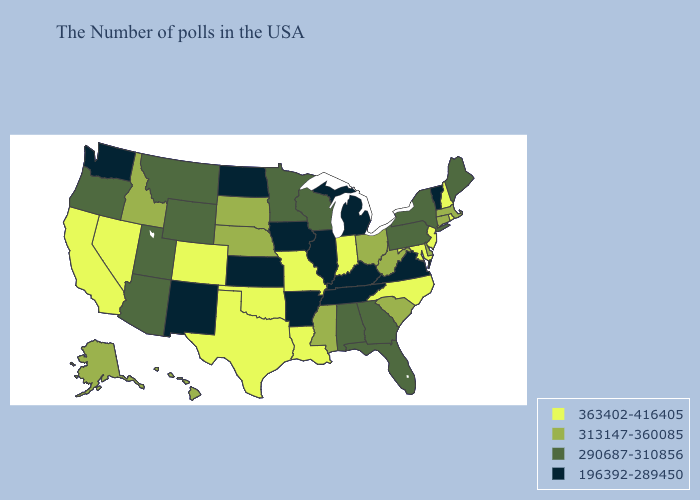Among the states that border West Virginia , does Maryland have the highest value?
Keep it brief. Yes. Does Nebraska have the highest value in the USA?
Give a very brief answer. No. What is the highest value in states that border Nevada?
Quick response, please. 363402-416405. Name the states that have a value in the range 290687-310856?
Give a very brief answer. Maine, New York, Pennsylvania, Florida, Georgia, Alabama, Wisconsin, Minnesota, Wyoming, Utah, Montana, Arizona, Oregon. Does the first symbol in the legend represent the smallest category?
Answer briefly. No. Among the states that border Maryland , does Virginia have the lowest value?
Short answer required. Yes. What is the value of Utah?
Concise answer only. 290687-310856. What is the highest value in the West ?
Quick response, please. 363402-416405. Name the states that have a value in the range 196392-289450?
Concise answer only. Vermont, Virginia, Michigan, Kentucky, Tennessee, Illinois, Arkansas, Iowa, Kansas, North Dakota, New Mexico, Washington. What is the lowest value in the USA?
Keep it brief. 196392-289450. What is the highest value in states that border West Virginia?
Short answer required. 363402-416405. What is the lowest value in the USA?
Quick response, please. 196392-289450. Name the states that have a value in the range 196392-289450?
Short answer required. Vermont, Virginia, Michigan, Kentucky, Tennessee, Illinois, Arkansas, Iowa, Kansas, North Dakota, New Mexico, Washington. Name the states that have a value in the range 196392-289450?
Write a very short answer. Vermont, Virginia, Michigan, Kentucky, Tennessee, Illinois, Arkansas, Iowa, Kansas, North Dakota, New Mexico, Washington. Among the states that border Idaho , which have the highest value?
Keep it brief. Nevada. 